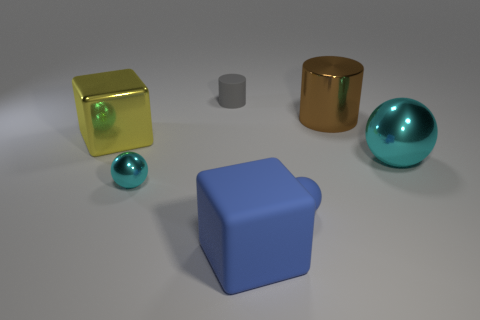Do the tiny shiny object and the big metallic sphere have the same color?
Your answer should be compact. Yes. There is a cube in front of the cyan object that is to the left of the large cube that is in front of the metallic cube; what is its material?
Keep it short and to the point. Rubber. Does the large cube behind the tiny cyan shiny ball have the same material as the gray thing?
Your answer should be compact. No. How many yellow blocks are the same size as the matte cylinder?
Make the answer very short. 0. Are there more big metal objects that are to the right of the large metallic block than small metal things to the right of the rubber cube?
Your answer should be compact. Yes. Is there a small blue matte object of the same shape as the large cyan metallic thing?
Offer a very short reply. Yes. What is the size of the cyan object on the left side of the matte object to the right of the blue rubber cube?
Offer a terse response. Small. What is the shape of the shiny thing on the right side of the cylinder right of the rubber object that is behind the brown cylinder?
Provide a succinct answer. Sphere. The block that is made of the same material as the large ball is what size?
Ensure brevity in your answer.  Large. Are there more big gray cubes than metallic cubes?
Provide a succinct answer. No. 